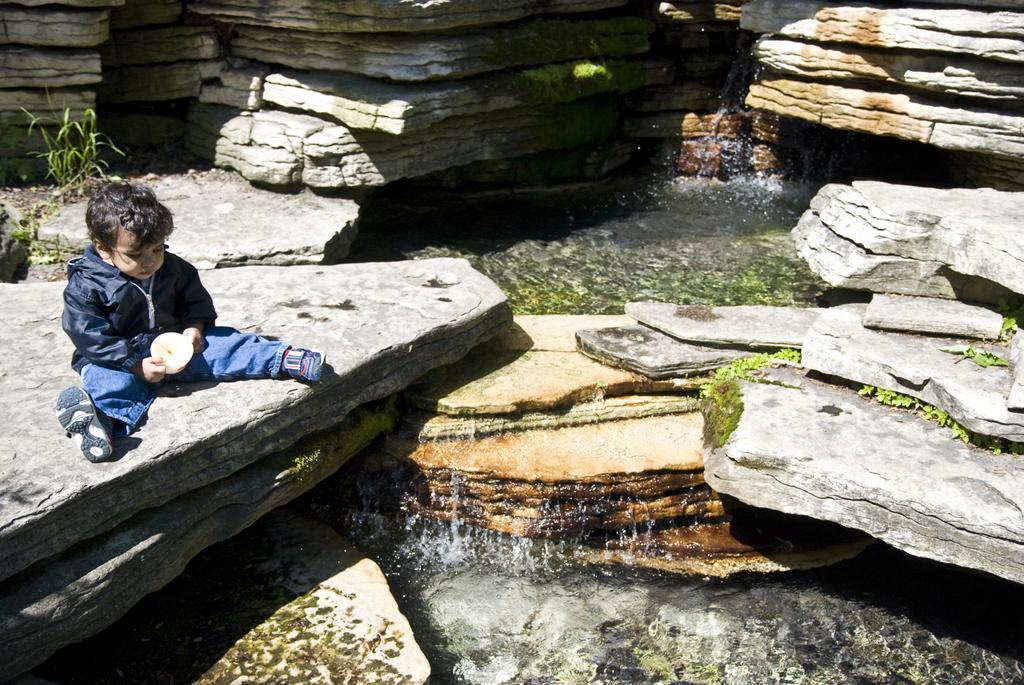What is the main subject of the image? The main subject of the image is a kid. What is the kid wearing in the image? The kid is wearing a black jacket in the image. Where is the kid sitting in the image? The kid is sitting on a stone in the image. What is the location of the stone in relation to the waterfall? The stone is in front of a waterfall in the image. What type of fowl can be seen interacting with the kid in the image? There is no fowl present in the image; the kid is sitting on a stone in front of a waterfall. Can you tell me how many family members are visible in the image? The image only shows a kid sitting on a stone, so it is not possible to determine the number of family members present. 